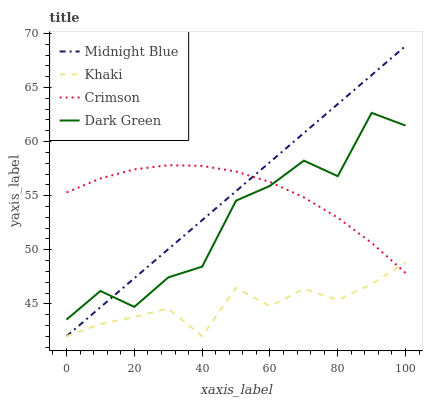Does Khaki have the minimum area under the curve?
Answer yes or no. Yes. Does Midnight Blue have the maximum area under the curve?
Answer yes or no. Yes. Does Midnight Blue have the minimum area under the curve?
Answer yes or no. No. Does Khaki have the maximum area under the curve?
Answer yes or no. No. Is Midnight Blue the smoothest?
Answer yes or no. Yes. Is Dark Green the roughest?
Answer yes or no. Yes. Is Khaki the smoothest?
Answer yes or no. No. Is Khaki the roughest?
Answer yes or no. No. Does Dark Green have the lowest value?
Answer yes or no. No. Does Midnight Blue have the highest value?
Answer yes or no. Yes. Does Khaki have the highest value?
Answer yes or no. No. Is Khaki less than Dark Green?
Answer yes or no. Yes. Is Dark Green greater than Khaki?
Answer yes or no. Yes. Does Midnight Blue intersect Crimson?
Answer yes or no. Yes. Is Midnight Blue less than Crimson?
Answer yes or no. No. Is Midnight Blue greater than Crimson?
Answer yes or no. No. Does Khaki intersect Dark Green?
Answer yes or no. No. 